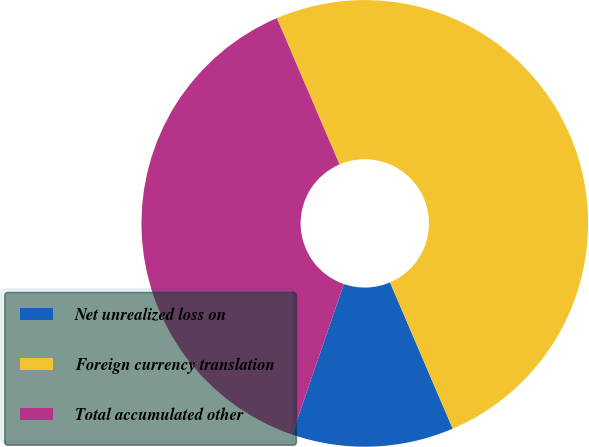Convert chart. <chart><loc_0><loc_0><loc_500><loc_500><pie_chart><fcel>Net unrealized loss on<fcel>Foreign currency translation<fcel>Total accumulated other<nl><fcel>11.72%<fcel>50.0%<fcel>38.28%<nl></chart> 